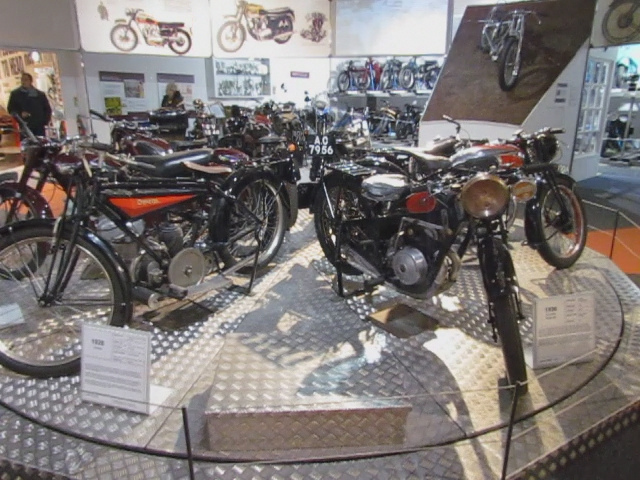Are these motorcycles functional or simply for display? While these motorcycles are currently on display in a showroom context, it is likely that many of them are kept in operational condition, particularly if the venue hosts demonstrations or allows for supervised test runs by enthusiasts and collectors. 